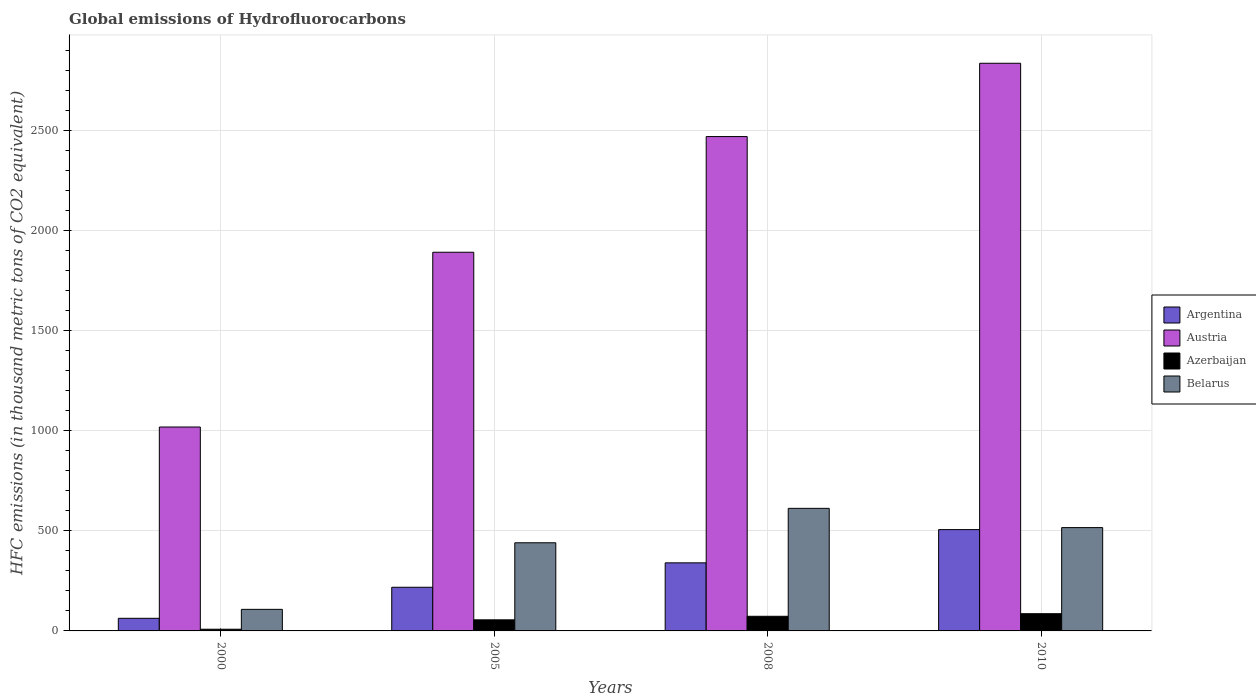How many bars are there on the 4th tick from the left?
Make the answer very short. 4. What is the label of the 1st group of bars from the left?
Offer a very short reply. 2000. In how many cases, is the number of bars for a given year not equal to the number of legend labels?
Make the answer very short. 0. What is the global emissions of Hydrofluorocarbons in Belarus in 2000?
Your response must be concise. 107.7. Across all years, what is the maximum global emissions of Hydrofluorocarbons in Austria?
Provide a short and direct response. 2835. In which year was the global emissions of Hydrofluorocarbons in Argentina maximum?
Offer a very short reply. 2010. What is the total global emissions of Hydrofluorocarbons in Belarus in the graph?
Provide a succinct answer. 1676. What is the difference between the global emissions of Hydrofluorocarbons in Argentina in 2005 and that in 2010?
Provide a succinct answer. -287.9. What is the difference between the global emissions of Hydrofluorocarbons in Azerbaijan in 2000 and the global emissions of Hydrofluorocarbons in Belarus in 2005?
Your response must be concise. -431.7. What is the average global emissions of Hydrofluorocarbons in Argentina per year?
Offer a very short reply. 281.77. In the year 2005, what is the difference between the global emissions of Hydrofluorocarbons in Argentina and global emissions of Hydrofluorocarbons in Austria?
Keep it short and to the point. -1673.1. In how many years, is the global emissions of Hydrofluorocarbons in Azerbaijan greater than 500 thousand metric tons?
Offer a very short reply. 0. What is the ratio of the global emissions of Hydrofluorocarbons in Argentina in 2005 to that in 2010?
Make the answer very short. 0.43. Is the global emissions of Hydrofluorocarbons in Austria in 2000 less than that in 2005?
Provide a succinct answer. Yes. Is the difference between the global emissions of Hydrofluorocarbons in Argentina in 2008 and 2010 greater than the difference between the global emissions of Hydrofluorocarbons in Austria in 2008 and 2010?
Provide a succinct answer. Yes. What is the difference between the highest and the second highest global emissions of Hydrofluorocarbons in Austria?
Provide a succinct answer. 366.1. What is the difference between the highest and the lowest global emissions of Hydrofluorocarbons in Belarus?
Your answer should be compact. 504.4. Is the sum of the global emissions of Hydrofluorocarbons in Azerbaijan in 2005 and 2008 greater than the maximum global emissions of Hydrofluorocarbons in Belarus across all years?
Your answer should be very brief. No. What does the 4th bar from the left in 2000 represents?
Your answer should be very brief. Belarus. Is it the case that in every year, the sum of the global emissions of Hydrofluorocarbons in Belarus and global emissions of Hydrofluorocarbons in Azerbaijan is greater than the global emissions of Hydrofluorocarbons in Austria?
Make the answer very short. No. How many years are there in the graph?
Make the answer very short. 4. What is the difference between two consecutive major ticks on the Y-axis?
Ensure brevity in your answer.  500. Does the graph contain any zero values?
Make the answer very short. No. Where does the legend appear in the graph?
Offer a terse response. Center right. How many legend labels are there?
Make the answer very short. 4. What is the title of the graph?
Offer a terse response. Global emissions of Hydrofluorocarbons. Does "Uzbekistan" appear as one of the legend labels in the graph?
Provide a short and direct response. No. What is the label or title of the X-axis?
Your response must be concise. Years. What is the label or title of the Y-axis?
Ensure brevity in your answer.  HFC emissions (in thousand metric tons of CO2 equivalent). What is the HFC emissions (in thousand metric tons of CO2 equivalent) in Austria in 2000?
Offer a terse response. 1018.4. What is the HFC emissions (in thousand metric tons of CO2 equivalent) of Belarus in 2000?
Provide a succinct answer. 107.7. What is the HFC emissions (in thousand metric tons of CO2 equivalent) of Argentina in 2005?
Keep it short and to the point. 218.1. What is the HFC emissions (in thousand metric tons of CO2 equivalent) in Austria in 2005?
Your answer should be compact. 1891.2. What is the HFC emissions (in thousand metric tons of CO2 equivalent) of Azerbaijan in 2005?
Your answer should be very brief. 55.4. What is the HFC emissions (in thousand metric tons of CO2 equivalent) in Belarus in 2005?
Offer a very short reply. 440.2. What is the HFC emissions (in thousand metric tons of CO2 equivalent) of Argentina in 2008?
Your answer should be very brief. 340. What is the HFC emissions (in thousand metric tons of CO2 equivalent) of Austria in 2008?
Your answer should be very brief. 2468.9. What is the HFC emissions (in thousand metric tons of CO2 equivalent) of Azerbaijan in 2008?
Keep it short and to the point. 73.1. What is the HFC emissions (in thousand metric tons of CO2 equivalent) in Belarus in 2008?
Make the answer very short. 612.1. What is the HFC emissions (in thousand metric tons of CO2 equivalent) of Argentina in 2010?
Offer a terse response. 506. What is the HFC emissions (in thousand metric tons of CO2 equivalent) in Austria in 2010?
Your answer should be very brief. 2835. What is the HFC emissions (in thousand metric tons of CO2 equivalent) in Belarus in 2010?
Give a very brief answer. 516. Across all years, what is the maximum HFC emissions (in thousand metric tons of CO2 equivalent) of Argentina?
Provide a short and direct response. 506. Across all years, what is the maximum HFC emissions (in thousand metric tons of CO2 equivalent) in Austria?
Your response must be concise. 2835. Across all years, what is the maximum HFC emissions (in thousand metric tons of CO2 equivalent) in Belarus?
Your response must be concise. 612.1. Across all years, what is the minimum HFC emissions (in thousand metric tons of CO2 equivalent) in Argentina?
Offer a terse response. 63. Across all years, what is the minimum HFC emissions (in thousand metric tons of CO2 equivalent) in Austria?
Keep it short and to the point. 1018.4. Across all years, what is the minimum HFC emissions (in thousand metric tons of CO2 equivalent) in Belarus?
Ensure brevity in your answer.  107.7. What is the total HFC emissions (in thousand metric tons of CO2 equivalent) in Argentina in the graph?
Ensure brevity in your answer.  1127.1. What is the total HFC emissions (in thousand metric tons of CO2 equivalent) of Austria in the graph?
Give a very brief answer. 8213.5. What is the total HFC emissions (in thousand metric tons of CO2 equivalent) in Azerbaijan in the graph?
Keep it short and to the point. 223. What is the total HFC emissions (in thousand metric tons of CO2 equivalent) of Belarus in the graph?
Your response must be concise. 1676. What is the difference between the HFC emissions (in thousand metric tons of CO2 equivalent) in Argentina in 2000 and that in 2005?
Provide a short and direct response. -155.1. What is the difference between the HFC emissions (in thousand metric tons of CO2 equivalent) in Austria in 2000 and that in 2005?
Provide a short and direct response. -872.8. What is the difference between the HFC emissions (in thousand metric tons of CO2 equivalent) of Azerbaijan in 2000 and that in 2005?
Provide a succinct answer. -46.9. What is the difference between the HFC emissions (in thousand metric tons of CO2 equivalent) in Belarus in 2000 and that in 2005?
Your answer should be compact. -332.5. What is the difference between the HFC emissions (in thousand metric tons of CO2 equivalent) of Argentina in 2000 and that in 2008?
Provide a succinct answer. -277. What is the difference between the HFC emissions (in thousand metric tons of CO2 equivalent) of Austria in 2000 and that in 2008?
Offer a terse response. -1450.5. What is the difference between the HFC emissions (in thousand metric tons of CO2 equivalent) of Azerbaijan in 2000 and that in 2008?
Provide a succinct answer. -64.6. What is the difference between the HFC emissions (in thousand metric tons of CO2 equivalent) of Belarus in 2000 and that in 2008?
Keep it short and to the point. -504.4. What is the difference between the HFC emissions (in thousand metric tons of CO2 equivalent) of Argentina in 2000 and that in 2010?
Offer a terse response. -443. What is the difference between the HFC emissions (in thousand metric tons of CO2 equivalent) in Austria in 2000 and that in 2010?
Give a very brief answer. -1816.6. What is the difference between the HFC emissions (in thousand metric tons of CO2 equivalent) in Azerbaijan in 2000 and that in 2010?
Offer a very short reply. -77.5. What is the difference between the HFC emissions (in thousand metric tons of CO2 equivalent) in Belarus in 2000 and that in 2010?
Ensure brevity in your answer.  -408.3. What is the difference between the HFC emissions (in thousand metric tons of CO2 equivalent) in Argentina in 2005 and that in 2008?
Offer a very short reply. -121.9. What is the difference between the HFC emissions (in thousand metric tons of CO2 equivalent) of Austria in 2005 and that in 2008?
Your answer should be very brief. -577.7. What is the difference between the HFC emissions (in thousand metric tons of CO2 equivalent) of Azerbaijan in 2005 and that in 2008?
Make the answer very short. -17.7. What is the difference between the HFC emissions (in thousand metric tons of CO2 equivalent) in Belarus in 2005 and that in 2008?
Your answer should be compact. -171.9. What is the difference between the HFC emissions (in thousand metric tons of CO2 equivalent) of Argentina in 2005 and that in 2010?
Your response must be concise. -287.9. What is the difference between the HFC emissions (in thousand metric tons of CO2 equivalent) of Austria in 2005 and that in 2010?
Offer a terse response. -943.8. What is the difference between the HFC emissions (in thousand metric tons of CO2 equivalent) in Azerbaijan in 2005 and that in 2010?
Your answer should be compact. -30.6. What is the difference between the HFC emissions (in thousand metric tons of CO2 equivalent) in Belarus in 2005 and that in 2010?
Your answer should be very brief. -75.8. What is the difference between the HFC emissions (in thousand metric tons of CO2 equivalent) in Argentina in 2008 and that in 2010?
Ensure brevity in your answer.  -166. What is the difference between the HFC emissions (in thousand metric tons of CO2 equivalent) in Austria in 2008 and that in 2010?
Offer a terse response. -366.1. What is the difference between the HFC emissions (in thousand metric tons of CO2 equivalent) in Belarus in 2008 and that in 2010?
Give a very brief answer. 96.1. What is the difference between the HFC emissions (in thousand metric tons of CO2 equivalent) in Argentina in 2000 and the HFC emissions (in thousand metric tons of CO2 equivalent) in Austria in 2005?
Offer a terse response. -1828.2. What is the difference between the HFC emissions (in thousand metric tons of CO2 equivalent) of Argentina in 2000 and the HFC emissions (in thousand metric tons of CO2 equivalent) of Azerbaijan in 2005?
Offer a terse response. 7.6. What is the difference between the HFC emissions (in thousand metric tons of CO2 equivalent) of Argentina in 2000 and the HFC emissions (in thousand metric tons of CO2 equivalent) of Belarus in 2005?
Keep it short and to the point. -377.2. What is the difference between the HFC emissions (in thousand metric tons of CO2 equivalent) of Austria in 2000 and the HFC emissions (in thousand metric tons of CO2 equivalent) of Azerbaijan in 2005?
Provide a short and direct response. 963. What is the difference between the HFC emissions (in thousand metric tons of CO2 equivalent) in Austria in 2000 and the HFC emissions (in thousand metric tons of CO2 equivalent) in Belarus in 2005?
Offer a very short reply. 578.2. What is the difference between the HFC emissions (in thousand metric tons of CO2 equivalent) of Azerbaijan in 2000 and the HFC emissions (in thousand metric tons of CO2 equivalent) of Belarus in 2005?
Your answer should be very brief. -431.7. What is the difference between the HFC emissions (in thousand metric tons of CO2 equivalent) in Argentina in 2000 and the HFC emissions (in thousand metric tons of CO2 equivalent) in Austria in 2008?
Make the answer very short. -2405.9. What is the difference between the HFC emissions (in thousand metric tons of CO2 equivalent) in Argentina in 2000 and the HFC emissions (in thousand metric tons of CO2 equivalent) in Belarus in 2008?
Give a very brief answer. -549.1. What is the difference between the HFC emissions (in thousand metric tons of CO2 equivalent) of Austria in 2000 and the HFC emissions (in thousand metric tons of CO2 equivalent) of Azerbaijan in 2008?
Give a very brief answer. 945.3. What is the difference between the HFC emissions (in thousand metric tons of CO2 equivalent) of Austria in 2000 and the HFC emissions (in thousand metric tons of CO2 equivalent) of Belarus in 2008?
Make the answer very short. 406.3. What is the difference between the HFC emissions (in thousand metric tons of CO2 equivalent) in Azerbaijan in 2000 and the HFC emissions (in thousand metric tons of CO2 equivalent) in Belarus in 2008?
Your response must be concise. -603.6. What is the difference between the HFC emissions (in thousand metric tons of CO2 equivalent) of Argentina in 2000 and the HFC emissions (in thousand metric tons of CO2 equivalent) of Austria in 2010?
Provide a short and direct response. -2772. What is the difference between the HFC emissions (in thousand metric tons of CO2 equivalent) of Argentina in 2000 and the HFC emissions (in thousand metric tons of CO2 equivalent) of Belarus in 2010?
Your answer should be compact. -453. What is the difference between the HFC emissions (in thousand metric tons of CO2 equivalent) of Austria in 2000 and the HFC emissions (in thousand metric tons of CO2 equivalent) of Azerbaijan in 2010?
Make the answer very short. 932.4. What is the difference between the HFC emissions (in thousand metric tons of CO2 equivalent) of Austria in 2000 and the HFC emissions (in thousand metric tons of CO2 equivalent) of Belarus in 2010?
Make the answer very short. 502.4. What is the difference between the HFC emissions (in thousand metric tons of CO2 equivalent) in Azerbaijan in 2000 and the HFC emissions (in thousand metric tons of CO2 equivalent) in Belarus in 2010?
Provide a succinct answer. -507.5. What is the difference between the HFC emissions (in thousand metric tons of CO2 equivalent) in Argentina in 2005 and the HFC emissions (in thousand metric tons of CO2 equivalent) in Austria in 2008?
Keep it short and to the point. -2250.8. What is the difference between the HFC emissions (in thousand metric tons of CO2 equivalent) in Argentina in 2005 and the HFC emissions (in thousand metric tons of CO2 equivalent) in Azerbaijan in 2008?
Your answer should be compact. 145. What is the difference between the HFC emissions (in thousand metric tons of CO2 equivalent) in Argentina in 2005 and the HFC emissions (in thousand metric tons of CO2 equivalent) in Belarus in 2008?
Your response must be concise. -394. What is the difference between the HFC emissions (in thousand metric tons of CO2 equivalent) of Austria in 2005 and the HFC emissions (in thousand metric tons of CO2 equivalent) of Azerbaijan in 2008?
Ensure brevity in your answer.  1818.1. What is the difference between the HFC emissions (in thousand metric tons of CO2 equivalent) of Austria in 2005 and the HFC emissions (in thousand metric tons of CO2 equivalent) of Belarus in 2008?
Your answer should be very brief. 1279.1. What is the difference between the HFC emissions (in thousand metric tons of CO2 equivalent) in Azerbaijan in 2005 and the HFC emissions (in thousand metric tons of CO2 equivalent) in Belarus in 2008?
Your answer should be very brief. -556.7. What is the difference between the HFC emissions (in thousand metric tons of CO2 equivalent) in Argentina in 2005 and the HFC emissions (in thousand metric tons of CO2 equivalent) in Austria in 2010?
Ensure brevity in your answer.  -2616.9. What is the difference between the HFC emissions (in thousand metric tons of CO2 equivalent) in Argentina in 2005 and the HFC emissions (in thousand metric tons of CO2 equivalent) in Azerbaijan in 2010?
Provide a succinct answer. 132.1. What is the difference between the HFC emissions (in thousand metric tons of CO2 equivalent) of Argentina in 2005 and the HFC emissions (in thousand metric tons of CO2 equivalent) of Belarus in 2010?
Provide a short and direct response. -297.9. What is the difference between the HFC emissions (in thousand metric tons of CO2 equivalent) in Austria in 2005 and the HFC emissions (in thousand metric tons of CO2 equivalent) in Azerbaijan in 2010?
Keep it short and to the point. 1805.2. What is the difference between the HFC emissions (in thousand metric tons of CO2 equivalent) in Austria in 2005 and the HFC emissions (in thousand metric tons of CO2 equivalent) in Belarus in 2010?
Give a very brief answer. 1375.2. What is the difference between the HFC emissions (in thousand metric tons of CO2 equivalent) in Azerbaijan in 2005 and the HFC emissions (in thousand metric tons of CO2 equivalent) in Belarus in 2010?
Your answer should be compact. -460.6. What is the difference between the HFC emissions (in thousand metric tons of CO2 equivalent) of Argentina in 2008 and the HFC emissions (in thousand metric tons of CO2 equivalent) of Austria in 2010?
Your response must be concise. -2495. What is the difference between the HFC emissions (in thousand metric tons of CO2 equivalent) in Argentina in 2008 and the HFC emissions (in thousand metric tons of CO2 equivalent) in Azerbaijan in 2010?
Your answer should be very brief. 254. What is the difference between the HFC emissions (in thousand metric tons of CO2 equivalent) of Argentina in 2008 and the HFC emissions (in thousand metric tons of CO2 equivalent) of Belarus in 2010?
Your answer should be compact. -176. What is the difference between the HFC emissions (in thousand metric tons of CO2 equivalent) in Austria in 2008 and the HFC emissions (in thousand metric tons of CO2 equivalent) in Azerbaijan in 2010?
Make the answer very short. 2382.9. What is the difference between the HFC emissions (in thousand metric tons of CO2 equivalent) in Austria in 2008 and the HFC emissions (in thousand metric tons of CO2 equivalent) in Belarus in 2010?
Offer a very short reply. 1952.9. What is the difference between the HFC emissions (in thousand metric tons of CO2 equivalent) in Azerbaijan in 2008 and the HFC emissions (in thousand metric tons of CO2 equivalent) in Belarus in 2010?
Make the answer very short. -442.9. What is the average HFC emissions (in thousand metric tons of CO2 equivalent) of Argentina per year?
Provide a short and direct response. 281.77. What is the average HFC emissions (in thousand metric tons of CO2 equivalent) in Austria per year?
Provide a succinct answer. 2053.38. What is the average HFC emissions (in thousand metric tons of CO2 equivalent) in Azerbaijan per year?
Make the answer very short. 55.75. What is the average HFC emissions (in thousand metric tons of CO2 equivalent) of Belarus per year?
Your answer should be compact. 419. In the year 2000, what is the difference between the HFC emissions (in thousand metric tons of CO2 equivalent) in Argentina and HFC emissions (in thousand metric tons of CO2 equivalent) in Austria?
Offer a terse response. -955.4. In the year 2000, what is the difference between the HFC emissions (in thousand metric tons of CO2 equivalent) in Argentina and HFC emissions (in thousand metric tons of CO2 equivalent) in Azerbaijan?
Your answer should be very brief. 54.5. In the year 2000, what is the difference between the HFC emissions (in thousand metric tons of CO2 equivalent) of Argentina and HFC emissions (in thousand metric tons of CO2 equivalent) of Belarus?
Offer a very short reply. -44.7. In the year 2000, what is the difference between the HFC emissions (in thousand metric tons of CO2 equivalent) of Austria and HFC emissions (in thousand metric tons of CO2 equivalent) of Azerbaijan?
Give a very brief answer. 1009.9. In the year 2000, what is the difference between the HFC emissions (in thousand metric tons of CO2 equivalent) in Austria and HFC emissions (in thousand metric tons of CO2 equivalent) in Belarus?
Provide a short and direct response. 910.7. In the year 2000, what is the difference between the HFC emissions (in thousand metric tons of CO2 equivalent) in Azerbaijan and HFC emissions (in thousand metric tons of CO2 equivalent) in Belarus?
Provide a short and direct response. -99.2. In the year 2005, what is the difference between the HFC emissions (in thousand metric tons of CO2 equivalent) of Argentina and HFC emissions (in thousand metric tons of CO2 equivalent) of Austria?
Make the answer very short. -1673.1. In the year 2005, what is the difference between the HFC emissions (in thousand metric tons of CO2 equivalent) of Argentina and HFC emissions (in thousand metric tons of CO2 equivalent) of Azerbaijan?
Make the answer very short. 162.7. In the year 2005, what is the difference between the HFC emissions (in thousand metric tons of CO2 equivalent) of Argentina and HFC emissions (in thousand metric tons of CO2 equivalent) of Belarus?
Make the answer very short. -222.1. In the year 2005, what is the difference between the HFC emissions (in thousand metric tons of CO2 equivalent) in Austria and HFC emissions (in thousand metric tons of CO2 equivalent) in Azerbaijan?
Your response must be concise. 1835.8. In the year 2005, what is the difference between the HFC emissions (in thousand metric tons of CO2 equivalent) in Austria and HFC emissions (in thousand metric tons of CO2 equivalent) in Belarus?
Provide a succinct answer. 1451. In the year 2005, what is the difference between the HFC emissions (in thousand metric tons of CO2 equivalent) in Azerbaijan and HFC emissions (in thousand metric tons of CO2 equivalent) in Belarus?
Ensure brevity in your answer.  -384.8. In the year 2008, what is the difference between the HFC emissions (in thousand metric tons of CO2 equivalent) in Argentina and HFC emissions (in thousand metric tons of CO2 equivalent) in Austria?
Provide a succinct answer. -2128.9. In the year 2008, what is the difference between the HFC emissions (in thousand metric tons of CO2 equivalent) of Argentina and HFC emissions (in thousand metric tons of CO2 equivalent) of Azerbaijan?
Offer a terse response. 266.9. In the year 2008, what is the difference between the HFC emissions (in thousand metric tons of CO2 equivalent) of Argentina and HFC emissions (in thousand metric tons of CO2 equivalent) of Belarus?
Offer a very short reply. -272.1. In the year 2008, what is the difference between the HFC emissions (in thousand metric tons of CO2 equivalent) of Austria and HFC emissions (in thousand metric tons of CO2 equivalent) of Azerbaijan?
Give a very brief answer. 2395.8. In the year 2008, what is the difference between the HFC emissions (in thousand metric tons of CO2 equivalent) in Austria and HFC emissions (in thousand metric tons of CO2 equivalent) in Belarus?
Your response must be concise. 1856.8. In the year 2008, what is the difference between the HFC emissions (in thousand metric tons of CO2 equivalent) of Azerbaijan and HFC emissions (in thousand metric tons of CO2 equivalent) of Belarus?
Your response must be concise. -539. In the year 2010, what is the difference between the HFC emissions (in thousand metric tons of CO2 equivalent) in Argentina and HFC emissions (in thousand metric tons of CO2 equivalent) in Austria?
Offer a terse response. -2329. In the year 2010, what is the difference between the HFC emissions (in thousand metric tons of CO2 equivalent) in Argentina and HFC emissions (in thousand metric tons of CO2 equivalent) in Azerbaijan?
Provide a succinct answer. 420. In the year 2010, what is the difference between the HFC emissions (in thousand metric tons of CO2 equivalent) of Austria and HFC emissions (in thousand metric tons of CO2 equivalent) of Azerbaijan?
Provide a short and direct response. 2749. In the year 2010, what is the difference between the HFC emissions (in thousand metric tons of CO2 equivalent) of Austria and HFC emissions (in thousand metric tons of CO2 equivalent) of Belarus?
Keep it short and to the point. 2319. In the year 2010, what is the difference between the HFC emissions (in thousand metric tons of CO2 equivalent) of Azerbaijan and HFC emissions (in thousand metric tons of CO2 equivalent) of Belarus?
Your answer should be very brief. -430. What is the ratio of the HFC emissions (in thousand metric tons of CO2 equivalent) in Argentina in 2000 to that in 2005?
Provide a short and direct response. 0.29. What is the ratio of the HFC emissions (in thousand metric tons of CO2 equivalent) of Austria in 2000 to that in 2005?
Ensure brevity in your answer.  0.54. What is the ratio of the HFC emissions (in thousand metric tons of CO2 equivalent) of Azerbaijan in 2000 to that in 2005?
Ensure brevity in your answer.  0.15. What is the ratio of the HFC emissions (in thousand metric tons of CO2 equivalent) in Belarus in 2000 to that in 2005?
Provide a succinct answer. 0.24. What is the ratio of the HFC emissions (in thousand metric tons of CO2 equivalent) of Argentina in 2000 to that in 2008?
Offer a terse response. 0.19. What is the ratio of the HFC emissions (in thousand metric tons of CO2 equivalent) of Austria in 2000 to that in 2008?
Your answer should be compact. 0.41. What is the ratio of the HFC emissions (in thousand metric tons of CO2 equivalent) in Azerbaijan in 2000 to that in 2008?
Your answer should be very brief. 0.12. What is the ratio of the HFC emissions (in thousand metric tons of CO2 equivalent) of Belarus in 2000 to that in 2008?
Offer a terse response. 0.18. What is the ratio of the HFC emissions (in thousand metric tons of CO2 equivalent) in Argentina in 2000 to that in 2010?
Your answer should be very brief. 0.12. What is the ratio of the HFC emissions (in thousand metric tons of CO2 equivalent) in Austria in 2000 to that in 2010?
Offer a terse response. 0.36. What is the ratio of the HFC emissions (in thousand metric tons of CO2 equivalent) of Azerbaijan in 2000 to that in 2010?
Provide a short and direct response. 0.1. What is the ratio of the HFC emissions (in thousand metric tons of CO2 equivalent) in Belarus in 2000 to that in 2010?
Keep it short and to the point. 0.21. What is the ratio of the HFC emissions (in thousand metric tons of CO2 equivalent) of Argentina in 2005 to that in 2008?
Ensure brevity in your answer.  0.64. What is the ratio of the HFC emissions (in thousand metric tons of CO2 equivalent) of Austria in 2005 to that in 2008?
Offer a terse response. 0.77. What is the ratio of the HFC emissions (in thousand metric tons of CO2 equivalent) in Azerbaijan in 2005 to that in 2008?
Keep it short and to the point. 0.76. What is the ratio of the HFC emissions (in thousand metric tons of CO2 equivalent) of Belarus in 2005 to that in 2008?
Your response must be concise. 0.72. What is the ratio of the HFC emissions (in thousand metric tons of CO2 equivalent) of Argentina in 2005 to that in 2010?
Keep it short and to the point. 0.43. What is the ratio of the HFC emissions (in thousand metric tons of CO2 equivalent) of Austria in 2005 to that in 2010?
Provide a succinct answer. 0.67. What is the ratio of the HFC emissions (in thousand metric tons of CO2 equivalent) of Azerbaijan in 2005 to that in 2010?
Provide a short and direct response. 0.64. What is the ratio of the HFC emissions (in thousand metric tons of CO2 equivalent) of Belarus in 2005 to that in 2010?
Offer a very short reply. 0.85. What is the ratio of the HFC emissions (in thousand metric tons of CO2 equivalent) of Argentina in 2008 to that in 2010?
Offer a very short reply. 0.67. What is the ratio of the HFC emissions (in thousand metric tons of CO2 equivalent) of Austria in 2008 to that in 2010?
Offer a terse response. 0.87. What is the ratio of the HFC emissions (in thousand metric tons of CO2 equivalent) in Azerbaijan in 2008 to that in 2010?
Offer a terse response. 0.85. What is the ratio of the HFC emissions (in thousand metric tons of CO2 equivalent) of Belarus in 2008 to that in 2010?
Provide a succinct answer. 1.19. What is the difference between the highest and the second highest HFC emissions (in thousand metric tons of CO2 equivalent) of Argentina?
Your answer should be very brief. 166. What is the difference between the highest and the second highest HFC emissions (in thousand metric tons of CO2 equivalent) in Austria?
Your answer should be very brief. 366.1. What is the difference between the highest and the second highest HFC emissions (in thousand metric tons of CO2 equivalent) in Belarus?
Keep it short and to the point. 96.1. What is the difference between the highest and the lowest HFC emissions (in thousand metric tons of CO2 equivalent) in Argentina?
Offer a very short reply. 443. What is the difference between the highest and the lowest HFC emissions (in thousand metric tons of CO2 equivalent) of Austria?
Keep it short and to the point. 1816.6. What is the difference between the highest and the lowest HFC emissions (in thousand metric tons of CO2 equivalent) of Azerbaijan?
Offer a very short reply. 77.5. What is the difference between the highest and the lowest HFC emissions (in thousand metric tons of CO2 equivalent) of Belarus?
Ensure brevity in your answer.  504.4. 